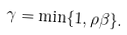Convert formula to latex. <formula><loc_0><loc_0><loc_500><loc_500>\gamma = \min \{ 1 , \rho \beta \} .</formula> 